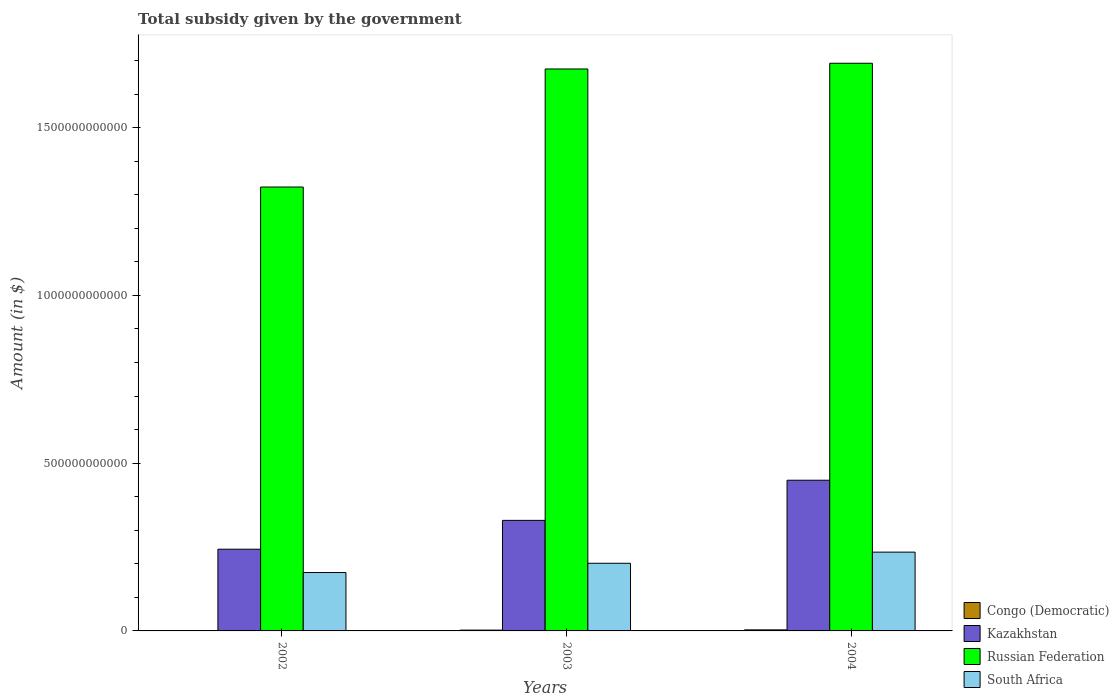How many different coloured bars are there?
Make the answer very short. 4. How many bars are there on the 1st tick from the left?
Your answer should be compact. 4. What is the total revenue collected by the government in South Africa in 2002?
Offer a terse response. 1.74e+11. Across all years, what is the maximum total revenue collected by the government in South Africa?
Provide a succinct answer. 2.35e+11. Across all years, what is the minimum total revenue collected by the government in Russian Federation?
Keep it short and to the point. 1.32e+12. What is the total total revenue collected by the government in Russian Federation in the graph?
Ensure brevity in your answer.  4.69e+12. What is the difference between the total revenue collected by the government in South Africa in 2002 and that in 2003?
Offer a very short reply. -2.76e+1. What is the difference between the total revenue collected by the government in Russian Federation in 2003 and the total revenue collected by the government in South Africa in 2002?
Keep it short and to the point. 1.50e+12. What is the average total revenue collected by the government in South Africa per year?
Give a very brief answer. 2.03e+11. In the year 2002, what is the difference between the total revenue collected by the government in South Africa and total revenue collected by the government in Russian Federation?
Give a very brief answer. -1.15e+12. What is the ratio of the total revenue collected by the government in Kazakhstan in 2002 to that in 2003?
Offer a terse response. 0.74. What is the difference between the highest and the second highest total revenue collected by the government in South Africa?
Offer a terse response. 3.32e+1. What is the difference between the highest and the lowest total revenue collected by the government in South Africa?
Offer a terse response. 6.09e+1. In how many years, is the total revenue collected by the government in Kazakhstan greater than the average total revenue collected by the government in Kazakhstan taken over all years?
Ensure brevity in your answer.  1. Is it the case that in every year, the sum of the total revenue collected by the government in Kazakhstan and total revenue collected by the government in Congo (Democratic) is greater than the sum of total revenue collected by the government in South Africa and total revenue collected by the government in Russian Federation?
Your response must be concise. No. What does the 3rd bar from the left in 2003 represents?
Ensure brevity in your answer.  Russian Federation. What does the 1st bar from the right in 2003 represents?
Keep it short and to the point. South Africa. How many bars are there?
Provide a short and direct response. 12. How many years are there in the graph?
Ensure brevity in your answer.  3. What is the difference between two consecutive major ticks on the Y-axis?
Offer a very short reply. 5.00e+11. Are the values on the major ticks of Y-axis written in scientific E-notation?
Your answer should be very brief. No. Does the graph contain any zero values?
Keep it short and to the point. No. Does the graph contain grids?
Provide a short and direct response. No. Where does the legend appear in the graph?
Provide a succinct answer. Bottom right. How are the legend labels stacked?
Provide a succinct answer. Vertical. What is the title of the graph?
Your answer should be compact. Total subsidy given by the government. Does "United Kingdom" appear as one of the legend labels in the graph?
Give a very brief answer. No. What is the label or title of the Y-axis?
Your answer should be compact. Amount (in $). What is the Amount (in $) of Congo (Democratic) in 2002?
Provide a succinct answer. 4.16e+08. What is the Amount (in $) in Kazakhstan in 2002?
Your answer should be very brief. 2.44e+11. What is the Amount (in $) of Russian Federation in 2002?
Offer a very short reply. 1.32e+12. What is the Amount (in $) in South Africa in 2002?
Provide a short and direct response. 1.74e+11. What is the Amount (in $) in Congo (Democratic) in 2003?
Your response must be concise. 2.38e+09. What is the Amount (in $) in Kazakhstan in 2003?
Provide a succinct answer. 3.29e+11. What is the Amount (in $) of Russian Federation in 2003?
Offer a very short reply. 1.67e+12. What is the Amount (in $) of South Africa in 2003?
Provide a short and direct response. 2.02e+11. What is the Amount (in $) of Congo (Democratic) in 2004?
Provide a short and direct response. 3.12e+09. What is the Amount (in $) in Kazakhstan in 2004?
Your response must be concise. 4.49e+11. What is the Amount (in $) in Russian Federation in 2004?
Make the answer very short. 1.69e+12. What is the Amount (in $) in South Africa in 2004?
Your answer should be compact. 2.35e+11. Across all years, what is the maximum Amount (in $) of Congo (Democratic)?
Provide a short and direct response. 3.12e+09. Across all years, what is the maximum Amount (in $) of Kazakhstan?
Provide a short and direct response. 4.49e+11. Across all years, what is the maximum Amount (in $) of Russian Federation?
Make the answer very short. 1.69e+12. Across all years, what is the maximum Amount (in $) of South Africa?
Offer a terse response. 2.35e+11. Across all years, what is the minimum Amount (in $) of Congo (Democratic)?
Keep it short and to the point. 4.16e+08. Across all years, what is the minimum Amount (in $) of Kazakhstan?
Offer a very short reply. 2.44e+11. Across all years, what is the minimum Amount (in $) in Russian Federation?
Provide a succinct answer. 1.32e+12. Across all years, what is the minimum Amount (in $) of South Africa?
Offer a very short reply. 1.74e+11. What is the total Amount (in $) of Congo (Democratic) in the graph?
Your answer should be very brief. 5.92e+09. What is the total Amount (in $) of Kazakhstan in the graph?
Your answer should be very brief. 1.02e+12. What is the total Amount (in $) of Russian Federation in the graph?
Your response must be concise. 4.69e+12. What is the total Amount (in $) of South Africa in the graph?
Your answer should be compact. 6.10e+11. What is the difference between the Amount (in $) in Congo (Democratic) in 2002 and that in 2003?
Keep it short and to the point. -1.96e+09. What is the difference between the Amount (in $) of Kazakhstan in 2002 and that in 2003?
Make the answer very short. -8.60e+1. What is the difference between the Amount (in $) of Russian Federation in 2002 and that in 2003?
Offer a terse response. -3.52e+11. What is the difference between the Amount (in $) of South Africa in 2002 and that in 2003?
Keep it short and to the point. -2.76e+1. What is the difference between the Amount (in $) of Congo (Democratic) in 2002 and that in 2004?
Offer a very short reply. -2.71e+09. What is the difference between the Amount (in $) in Kazakhstan in 2002 and that in 2004?
Provide a succinct answer. -2.06e+11. What is the difference between the Amount (in $) in Russian Federation in 2002 and that in 2004?
Keep it short and to the point. -3.69e+11. What is the difference between the Amount (in $) of South Africa in 2002 and that in 2004?
Offer a terse response. -6.09e+1. What is the difference between the Amount (in $) in Congo (Democratic) in 2003 and that in 2004?
Keep it short and to the point. -7.42e+08. What is the difference between the Amount (in $) of Kazakhstan in 2003 and that in 2004?
Your response must be concise. -1.20e+11. What is the difference between the Amount (in $) of Russian Federation in 2003 and that in 2004?
Ensure brevity in your answer.  -1.70e+1. What is the difference between the Amount (in $) of South Africa in 2003 and that in 2004?
Make the answer very short. -3.32e+1. What is the difference between the Amount (in $) in Congo (Democratic) in 2002 and the Amount (in $) in Kazakhstan in 2003?
Your response must be concise. -3.29e+11. What is the difference between the Amount (in $) of Congo (Democratic) in 2002 and the Amount (in $) of Russian Federation in 2003?
Provide a short and direct response. -1.67e+12. What is the difference between the Amount (in $) of Congo (Democratic) in 2002 and the Amount (in $) of South Africa in 2003?
Make the answer very short. -2.01e+11. What is the difference between the Amount (in $) of Kazakhstan in 2002 and the Amount (in $) of Russian Federation in 2003?
Make the answer very short. -1.43e+12. What is the difference between the Amount (in $) of Kazakhstan in 2002 and the Amount (in $) of South Africa in 2003?
Ensure brevity in your answer.  4.19e+1. What is the difference between the Amount (in $) of Russian Federation in 2002 and the Amount (in $) of South Africa in 2003?
Offer a terse response. 1.12e+12. What is the difference between the Amount (in $) in Congo (Democratic) in 2002 and the Amount (in $) in Kazakhstan in 2004?
Give a very brief answer. -4.49e+11. What is the difference between the Amount (in $) of Congo (Democratic) in 2002 and the Amount (in $) of Russian Federation in 2004?
Provide a short and direct response. -1.69e+12. What is the difference between the Amount (in $) in Congo (Democratic) in 2002 and the Amount (in $) in South Africa in 2004?
Keep it short and to the point. -2.34e+11. What is the difference between the Amount (in $) of Kazakhstan in 2002 and the Amount (in $) of Russian Federation in 2004?
Keep it short and to the point. -1.45e+12. What is the difference between the Amount (in $) of Kazakhstan in 2002 and the Amount (in $) of South Africa in 2004?
Provide a succinct answer. 8.69e+09. What is the difference between the Amount (in $) of Russian Federation in 2002 and the Amount (in $) of South Africa in 2004?
Ensure brevity in your answer.  1.09e+12. What is the difference between the Amount (in $) in Congo (Democratic) in 2003 and the Amount (in $) in Kazakhstan in 2004?
Ensure brevity in your answer.  -4.47e+11. What is the difference between the Amount (in $) in Congo (Democratic) in 2003 and the Amount (in $) in Russian Federation in 2004?
Provide a short and direct response. -1.69e+12. What is the difference between the Amount (in $) of Congo (Democratic) in 2003 and the Amount (in $) of South Africa in 2004?
Your response must be concise. -2.32e+11. What is the difference between the Amount (in $) in Kazakhstan in 2003 and the Amount (in $) in Russian Federation in 2004?
Offer a terse response. -1.36e+12. What is the difference between the Amount (in $) of Kazakhstan in 2003 and the Amount (in $) of South Africa in 2004?
Your answer should be very brief. 9.46e+1. What is the difference between the Amount (in $) in Russian Federation in 2003 and the Amount (in $) in South Africa in 2004?
Offer a terse response. 1.44e+12. What is the average Amount (in $) of Congo (Democratic) per year?
Your answer should be very brief. 1.97e+09. What is the average Amount (in $) of Kazakhstan per year?
Your answer should be compact. 3.41e+11. What is the average Amount (in $) of Russian Federation per year?
Offer a terse response. 1.56e+12. What is the average Amount (in $) of South Africa per year?
Keep it short and to the point. 2.03e+11. In the year 2002, what is the difference between the Amount (in $) in Congo (Democratic) and Amount (in $) in Kazakhstan?
Your answer should be very brief. -2.43e+11. In the year 2002, what is the difference between the Amount (in $) in Congo (Democratic) and Amount (in $) in Russian Federation?
Offer a terse response. -1.32e+12. In the year 2002, what is the difference between the Amount (in $) of Congo (Democratic) and Amount (in $) of South Africa?
Make the answer very short. -1.74e+11. In the year 2002, what is the difference between the Amount (in $) in Kazakhstan and Amount (in $) in Russian Federation?
Keep it short and to the point. -1.08e+12. In the year 2002, what is the difference between the Amount (in $) of Kazakhstan and Amount (in $) of South Africa?
Keep it short and to the point. 6.95e+1. In the year 2002, what is the difference between the Amount (in $) of Russian Federation and Amount (in $) of South Africa?
Give a very brief answer. 1.15e+12. In the year 2003, what is the difference between the Amount (in $) of Congo (Democratic) and Amount (in $) of Kazakhstan?
Keep it short and to the point. -3.27e+11. In the year 2003, what is the difference between the Amount (in $) of Congo (Democratic) and Amount (in $) of Russian Federation?
Offer a terse response. -1.67e+12. In the year 2003, what is the difference between the Amount (in $) in Congo (Democratic) and Amount (in $) in South Africa?
Your response must be concise. -1.99e+11. In the year 2003, what is the difference between the Amount (in $) of Kazakhstan and Amount (in $) of Russian Federation?
Provide a succinct answer. -1.35e+12. In the year 2003, what is the difference between the Amount (in $) of Kazakhstan and Amount (in $) of South Africa?
Keep it short and to the point. 1.28e+11. In the year 2003, what is the difference between the Amount (in $) in Russian Federation and Amount (in $) in South Africa?
Give a very brief answer. 1.47e+12. In the year 2004, what is the difference between the Amount (in $) of Congo (Democratic) and Amount (in $) of Kazakhstan?
Your response must be concise. -4.46e+11. In the year 2004, what is the difference between the Amount (in $) in Congo (Democratic) and Amount (in $) in Russian Federation?
Offer a terse response. -1.69e+12. In the year 2004, what is the difference between the Amount (in $) in Congo (Democratic) and Amount (in $) in South Africa?
Your answer should be very brief. -2.32e+11. In the year 2004, what is the difference between the Amount (in $) of Kazakhstan and Amount (in $) of Russian Federation?
Your answer should be very brief. -1.24e+12. In the year 2004, what is the difference between the Amount (in $) in Kazakhstan and Amount (in $) in South Africa?
Offer a terse response. 2.14e+11. In the year 2004, what is the difference between the Amount (in $) in Russian Federation and Amount (in $) in South Africa?
Your response must be concise. 1.46e+12. What is the ratio of the Amount (in $) in Congo (Democratic) in 2002 to that in 2003?
Offer a very short reply. 0.17. What is the ratio of the Amount (in $) in Kazakhstan in 2002 to that in 2003?
Offer a very short reply. 0.74. What is the ratio of the Amount (in $) of Russian Federation in 2002 to that in 2003?
Provide a short and direct response. 0.79. What is the ratio of the Amount (in $) in South Africa in 2002 to that in 2003?
Your answer should be compact. 0.86. What is the ratio of the Amount (in $) in Congo (Democratic) in 2002 to that in 2004?
Make the answer very short. 0.13. What is the ratio of the Amount (in $) in Kazakhstan in 2002 to that in 2004?
Provide a succinct answer. 0.54. What is the ratio of the Amount (in $) in Russian Federation in 2002 to that in 2004?
Provide a succinct answer. 0.78. What is the ratio of the Amount (in $) of South Africa in 2002 to that in 2004?
Your response must be concise. 0.74. What is the ratio of the Amount (in $) in Congo (Democratic) in 2003 to that in 2004?
Give a very brief answer. 0.76. What is the ratio of the Amount (in $) in Kazakhstan in 2003 to that in 2004?
Make the answer very short. 0.73. What is the ratio of the Amount (in $) in Russian Federation in 2003 to that in 2004?
Keep it short and to the point. 0.99. What is the ratio of the Amount (in $) of South Africa in 2003 to that in 2004?
Keep it short and to the point. 0.86. What is the difference between the highest and the second highest Amount (in $) of Congo (Democratic)?
Provide a short and direct response. 7.42e+08. What is the difference between the highest and the second highest Amount (in $) in Kazakhstan?
Keep it short and to the point. 1.20e+11. What is the difference between the highest and the second highest Amount (in $) in Russian Federation?
Provide a short and direct response. 1.70e+1. What is the difference between the highest and the second highest Amount (in $) in South Africa?
Give a very brief answer. 3.32e+1. What is the difference between the highest and the lowest Amount (in $) in Congo (Democratic)?
Your answer should be compact. 2.71e+09. What is the difference between the highest and the lowest Amount (in $) of Kazakhstan?
Your answer should be very brief. 2.06e+11. What is the difference between the highest and the lowest Amount (in $) of Russian Federation?
Your answer should be very brief. 3.69e+11. What is the difference between the highest and the lowest Amount (in $) in South Africa?
Provide a short and direct response. 6.09e+1. 